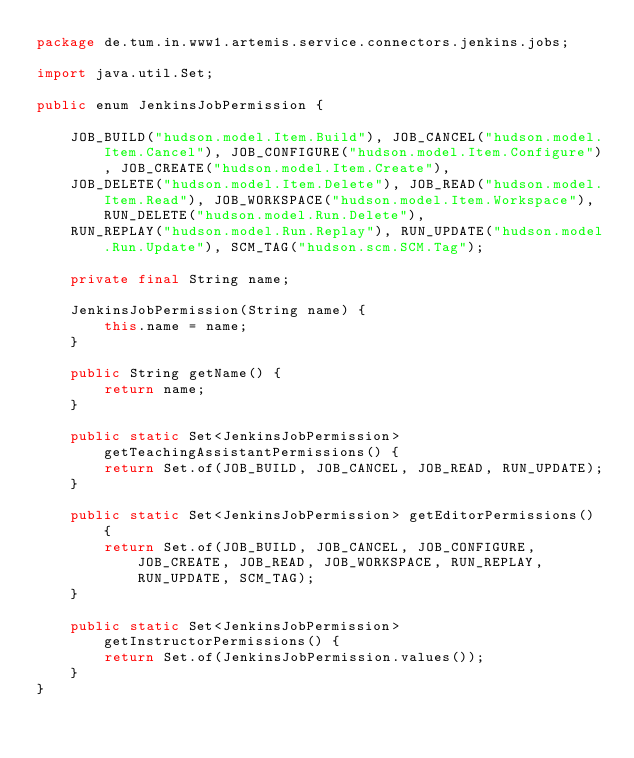<code> <loc_0><loc_0><loc_500><loc_500><_Java_>package de.tum.in.www1.artemis.service.connectors.jenkins.jobs;

import java.util.Set;

public enum JenkinsJobPermission {

    JOB_BUILD("hudson.model.Item.Build"), JOB_CANCEL("hudson.model.Item.Cancel"), JOB_CONFIGURE("hudson.model.Item.Configure"), JOB_CREATE("hudson.model.Item.Create"),
    JOB_DELETE("hudson.model.Item.Delete"), JOB_READ("hudson.model.Item.Read"), JOB_WORKSPACE("hudson.model.Item.Workspace"), RUN_DELETE("hudson.model.Run.Delete"),
    RUN_REPLAY("hudson.model.Run.Replay"), RUN_UPDATE("hudson.model.Run.Update"), SCM_TAG("hudson.scm.SCM.Tag");

    private final String name;

    JenkinsJobPermission(String name) {
        this.name = name;
    }

    public String getName() {
        return name;
    }

    public static Set<JenkinsJobPermission> getTeachingAssistantPermissions() {
        return Set.of(JOB_BUILD, JOB_CANCEL, JOB_READ, RUN_UPDATE);
    }

    public static Set<JenkinsJobPermission> getEditorPermissions() {
        return Set.of(JOB_BUILD, JOB_CANCEL, JOB_CONFIGURE, JOB_CREATE, JOB_READ, JOB_WORKSPACE, RUN_REPLAY, RUN_UPDATE, SCM_TAG);
    }

    public static Set<JenkinsJobPermission> getInstructorPermissions() {
        return Set.of(JenkinsJobPermission.values());
    }
}
</code> 